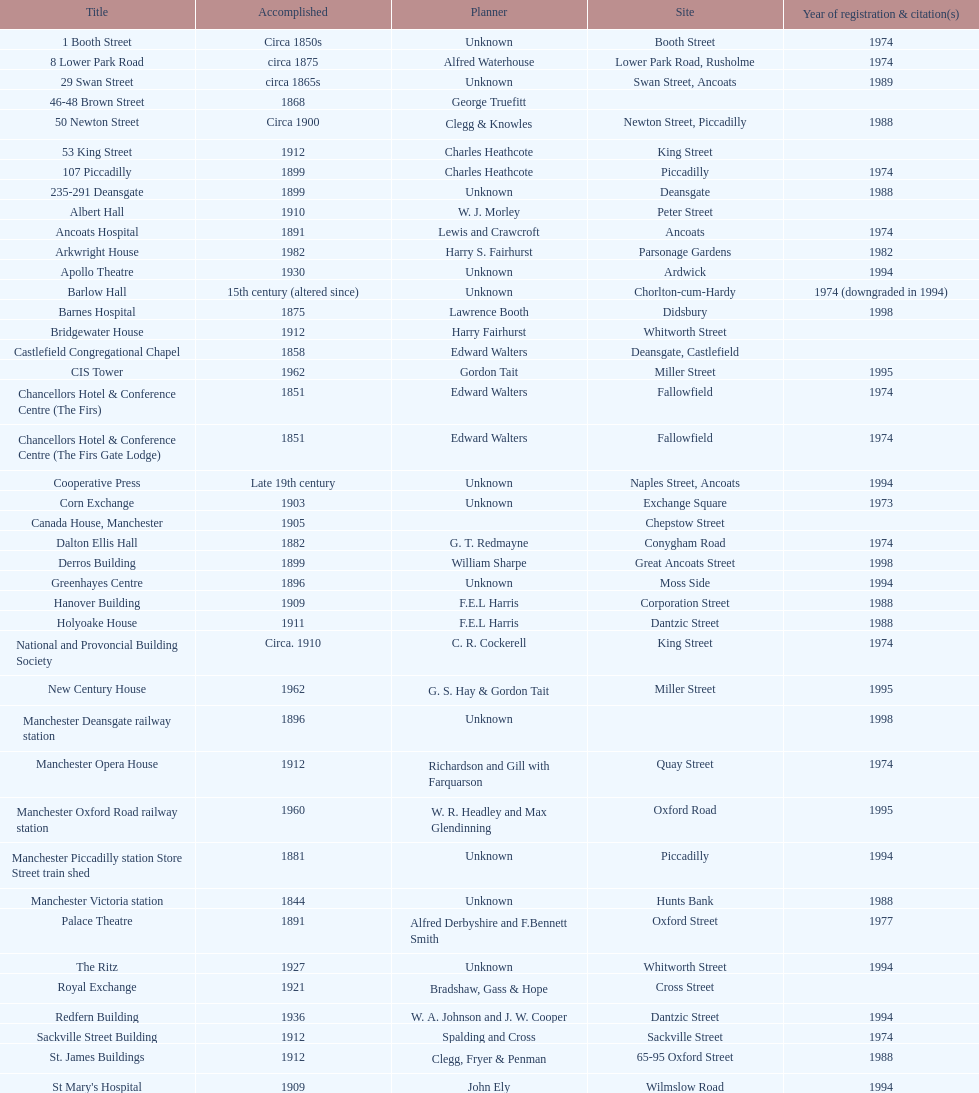Which year has the most buildings listed? 1974. 